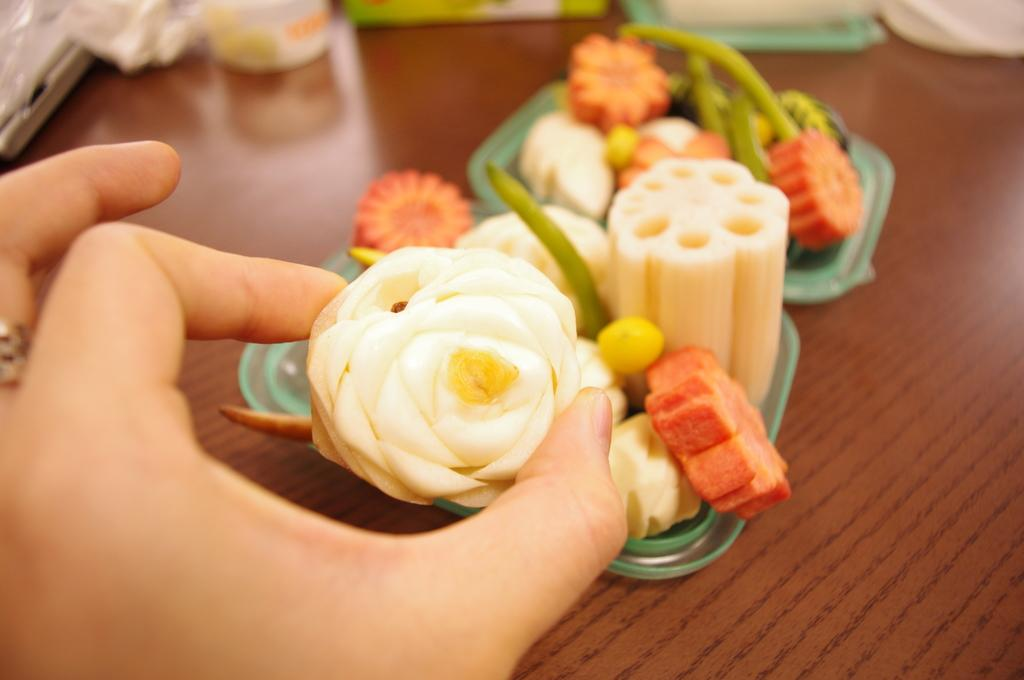What type of furniture is present in the image? There is a table in the image. Can you describe any body parts visible in the image? A human hand is visible in the image. What is placed on the table in the image? There are plates on the table. What is on the plates? The plates contain sweets. What type of doctor is standing near the table in the image? There is no doctor present in the image; only a table, plates, and sweets are visible. 